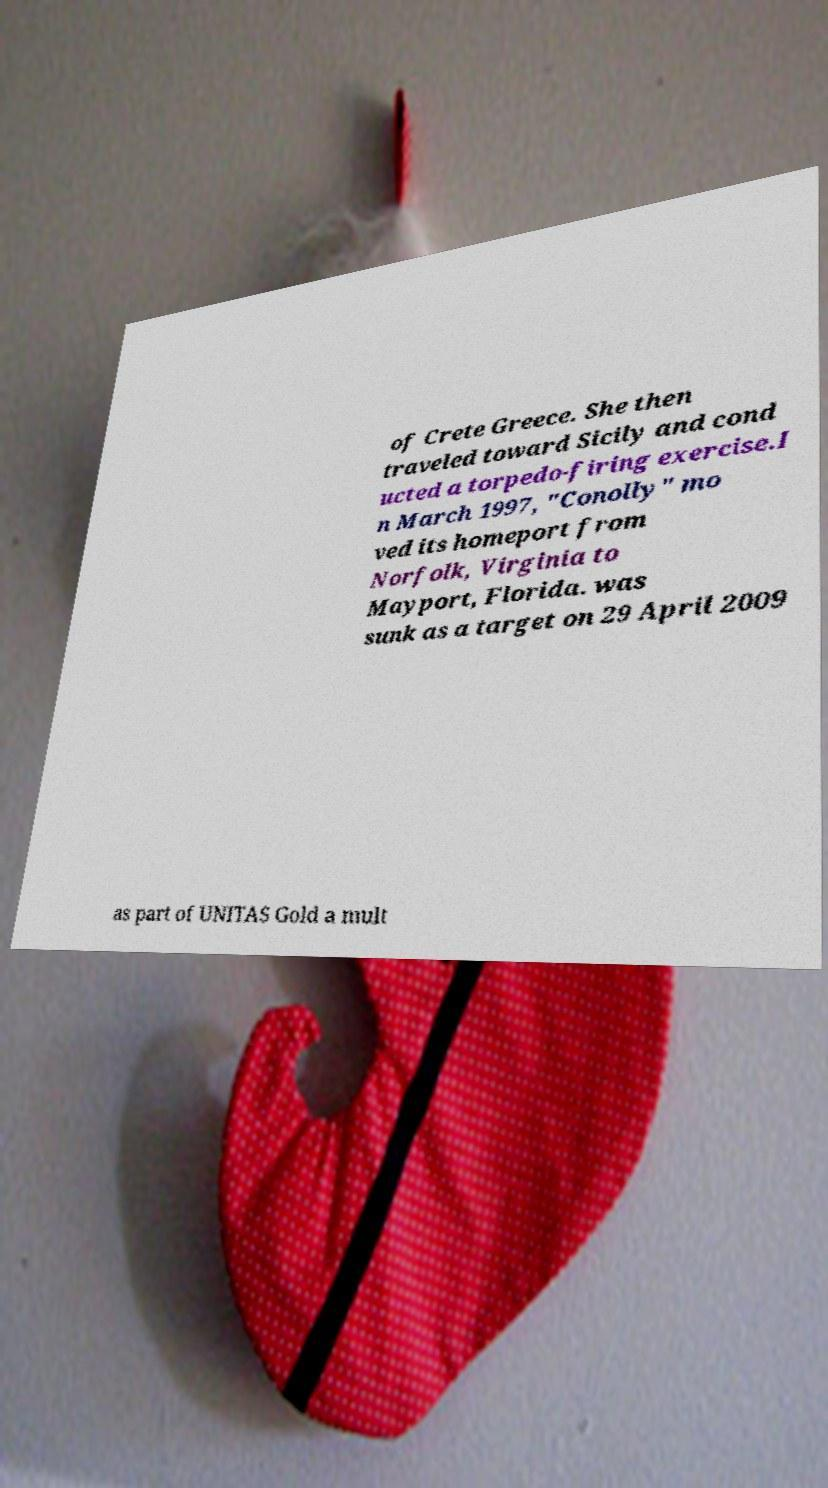There's text embedded in this image that I need extracted. Can you transcribe it verbatim? of Crete Greece. She then traveled toward Sicily and cond ucted a torpedo-firing exercise.I n March 1997, "Conolly" mo ved its homeport from Norfolk, Virginia to Mayport, Florida. was sunk as a target on 29 April 2009 as part of UNITAS Gold a mult 